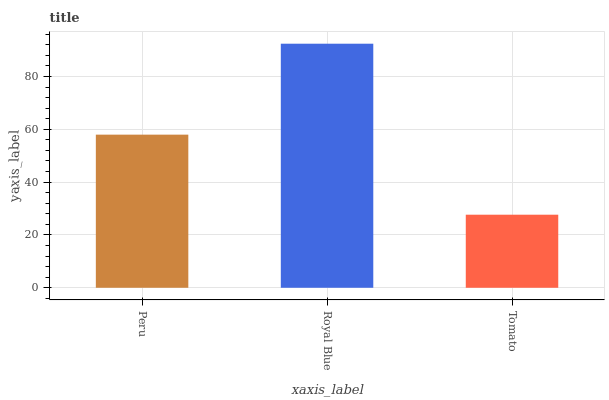Is Tomato the minimum?
Answer yes or no. Yes. Is Royal Blue the maximum?
Answer yes or no. Yes. Is Royal Blue the minimum?
Answer yes or no. No. Is Tomato the maximum?
Answer yes or no. No. Is Royal Blue greater than Tomato?
Answer yes or no. Yes. Is Tomato less than Royal Blue?
Answer yes or no. Yes. Is Tomato greater than Royal Blue?
Answer yes or no. No. Is Royal Blue less than Tomato?
Answer yes or no. No. Is Peru the high median?
Answer yes or no. Yes. Is Peru the low median?
Answer yes or no. Yes. Is Tomato the high median?
Answer yes or no. No. Is Tomato the low median?
Answer yes or no. No. 